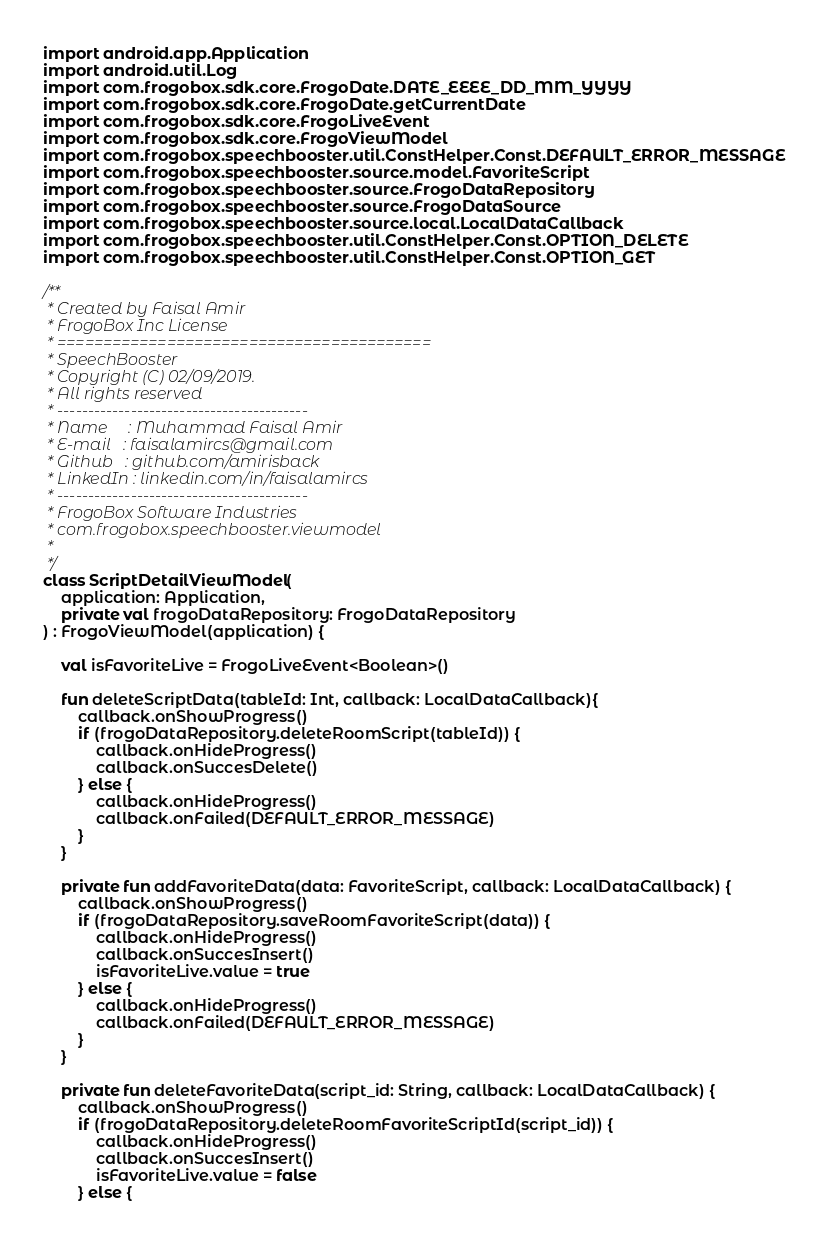Convert code to text. <code><loc_0><loc_0><loc_500><loc_500><_Kotlin_>
import android.app.Application
import android.util.Log
import com.frogobox.sdk.core.FrogoDate.DATE_EEEE_DD_MM_YYYY
import com.frogobox.sdk.core.FrogoDate.getCurrentDate
import com.frogobox.sdk.core.FrogoLiveEvent
import com.frogobox.sdk.core.FrogoViewModel
import com.frogobox.speechbooster.util.ConstHelper.Const.DEFAULT_ERROR_MESSAGE
import com.frogobox.speechbooster.source.model.FavoriteScript
import com.frogobox.speechbooster.source.FrogoDataRepository
import com.frogobox.speechbooster.source.FrogoDataSource
import com.frogobox.speechbooster.source.local.LocalDataCallback
import com.frogobox.speechbooster.util.ConstHelper.Const.OPTION_DELETE
import com.frogobox.speechbooster.util.ConstHelper.Const.OPTION_GET

/**
 * Created by Faisal Amir
 * FrogoBox Inc License
 * =========================================
 * SpeechBooster
 * Copyright (C) 02/09/2019.
 * All rights reserved
 * -----------------------------------------
 * Name     : Muhammad Faisal Amir
 * E-mail   : faisalamircs@gmail.com
 * Github   : github.com/amirisback
 * LinkedIn : linkedin.com/in/faisalamircs
 * -----------------------------------------
 * FrogoBox Software Industries
 * com.frogobox.speechbooster.viewmodel
 *
 */
class ScriptDetailViewModel(
    application: Application,
    private val frogoDataRepository: FrogoDataRepository
) : FrogoViewModel(application) {

    val isFavoriteLive = FrogoLiveEvent<Boolean>()

    fun deleteScriptData(tableId: Int, callback: LocalDataCallback){
        callback.onShowProgress()
        if (frogoDataRepository.deleteRoomScript(tableId)) {
            callback.onHideProgress()
            callback.onSuccesDelete()
        } else {
            callback.onHideProgress()
            callback.onFailed(DEFAULT_ERROR_MESSAGE)
        }
    }

    private fun addFavoriteData(data: FavoriteScript, callback: LocalDataCallback) {
        callback.onShowProgress()
        if (frogoDataRepository.saveRoomFavoriteScript(data)) {
            callback.onHideProgress()
            callback.onSuccesInsert()
            isFavoriteLive.value = true
        } else {
            callback.onHideProgress()
            callback.onFailed(DEFAULT_ERROR_MESSAGE)
        }
    }

    private fun deleteFavoriteData(script_id: String, callback: LocalDataCallback) {
        callback.onShowProgress()
        if (frogoDataRepository.deleteRoomFavoriteScriptId(script_id)) {
            callback.onHideProgress()
            callback.onSuccesInsert()
            isFavoriteLive.value = false
        } else {</code> 